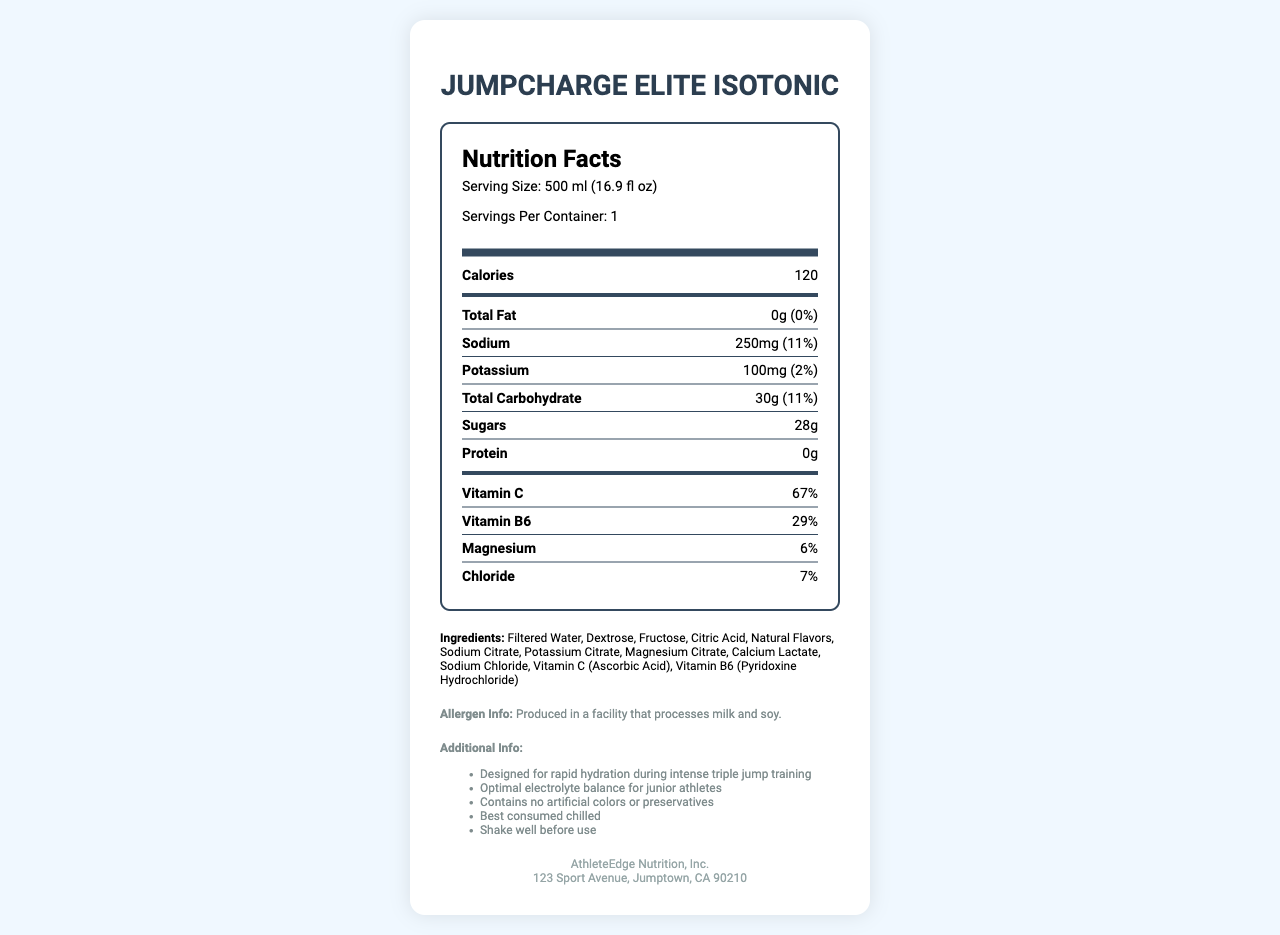what is the product name? The product name is clearly stated at the top of the document as "JumpCharge Elite Isotonic".
Answer: JumpCharge Elite Isotonic how many servings are there per container? The serving information indicates that there is 1 serving per container.
Answer: 1 what is the serving size? The serving size is specified as "500 ml (16.9 fl oz)" in the document.
Answer: 500 ml (16.9 fl oz) how many calories are in one serving? The nutrition facts section lists the calorie content as 120 per serving.
Answer: 120 calories how much sodium is in one serving? The amount of sodium per serving is listed as 250mg with a daily value of 11%.
Answer: 250mg what is the percentage of daily value for vitamin C? The daily value for vitamin C is given as 67%.
Answer: 67% what are the main ingredients in the drink? The document lists these ingredients: Filtered Water, Dextrose, Fructose, etc.
Answer: Filtered Water, Dextrose, Fructose, Citric Acid, Natural Flavors, Sodium Citrate, Potassium Citrate, Magnesium Citrate, Calcium Lactate, Sodium Chloride, Vitamin C (Ascorbic Acid), Vitamin B6 (Pyridoxine Hydrochloride) is there any fat in the drink? The total fat content is listed as 0g which means there is no fat in the drink.
Answer: No does the drink contain protein? The drink contains 0g of protein as stated in the nutrition facts.
Answer: No What is the daily value percentage of potassium in the drink? The daily value for potassium is listed as 2%.
Answer: 2% how should the drink be consumed for best results? A. Warm B. Room Temperature C. Chilled The additional information section specifies that the drink is best consumed chilled.
Answer: C. Chilled what allergen disclaimer is found on the label? A. Produced in a facility that processes peanuts B. Produced in a facility that processes milk and soy C. Contains nuts and dairy D. Free from common allergens The allergen information states that the product is produced in a facility that processes milk and soy.
Answer: B. Produced in a facility that processes milk and soy does the drink contain artificial colors or preservatives? The additional information specifies that the drink contains no artificial colors or preservatives.
Answer: No what is the total carbohydrate content per serving? The total carbohydrate content per serving is listed as 30g.
Answer: 30g what is the amount of sugars in one serving? The document states that there are 28g of sugars per serving.
Answer: 28g does the drink contain vitamin B6? The document lists Vitamin B6 (Pyridoxine Hydrochloride) as one of the ingredients.
Answer: Yes how much magnesium is in one serving? The daily value for magnesium is listed as 6%.
Answer: 6% of daily value is this drink suitable for junior athletes? The additional information specifies that the drink has an optimal electrolyte balance for junior athletes.
Answer: Yes who is the manufacturer of this drink? The manufacturer is listed as AthleteEdge Nutrition, Inc.
Answer: AthleteEdge Nutrition, Inc. what address is provided for the manufacturer? The document provides this address: 123 Sport Avenue, Jumptown, CA 90210.
Answer: 123 Sport Avenue, Jumptown, CA 90210 What is the main idea of the document? The document gives comprehensive nutrition facts about JumpCharge Elite Isotonic, highlighting its benefits for hydration and performance during intense triple jump training.
Answer: The document provides nutritional information for the sports drink JumpCharge Elite Isotonic, formulated to replenish electrolytes and designed for junior athletes. It details the serving size, calorie content, nutrients, ingredients, allergen info, and additional usage advice. What other products does AthleteEdge Nutrition, Inc. offer? The document does not provide details on other products offered by AthleteEdge Nutrition, Inc. It only focuses on JumpCharge Elite Isotonic.
Answer: Not enough information 